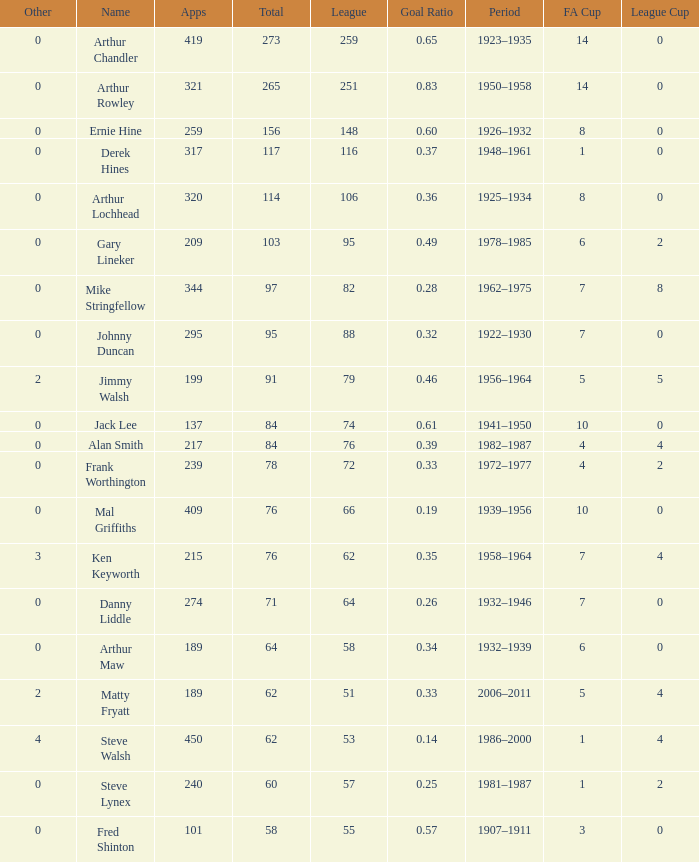What's the Highest Goal Ratio with a League of 88 and an FA Cup less than 7? None. 